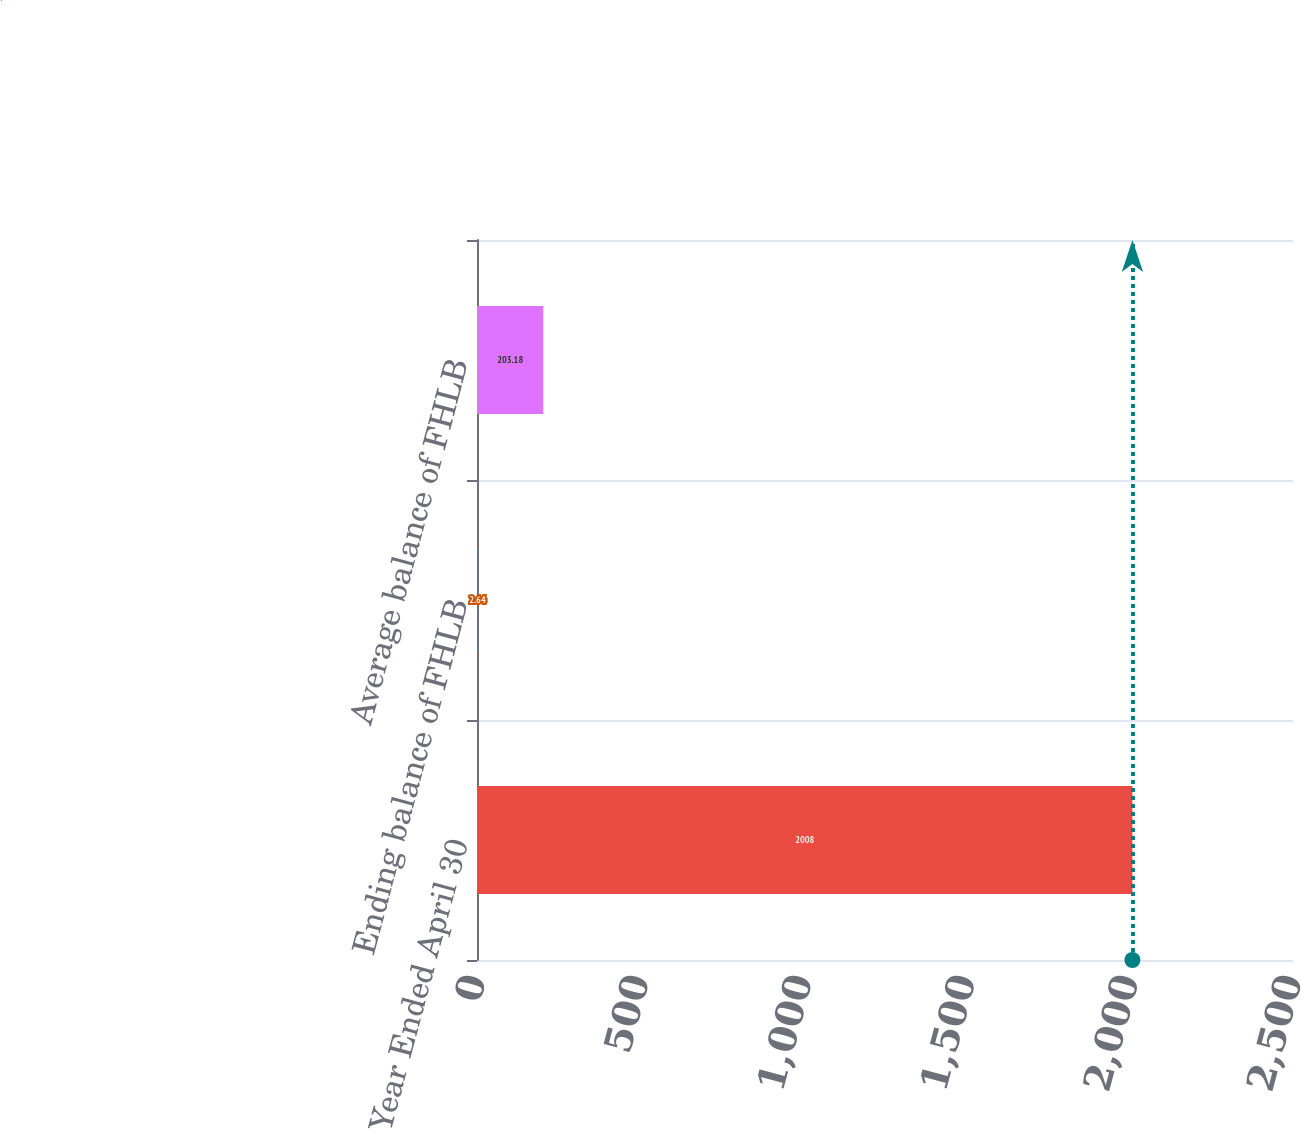Convert chart. <chart><loc_0><loc_0><loc_500><loc_500><bar_chart><fcel>Year Ended April 30<fcel>Ending balance of FHLB<fcel>Average balance of FHLB<nl><fcel>2008<fcel>2.64<fcel>203.18<nl></chart> 